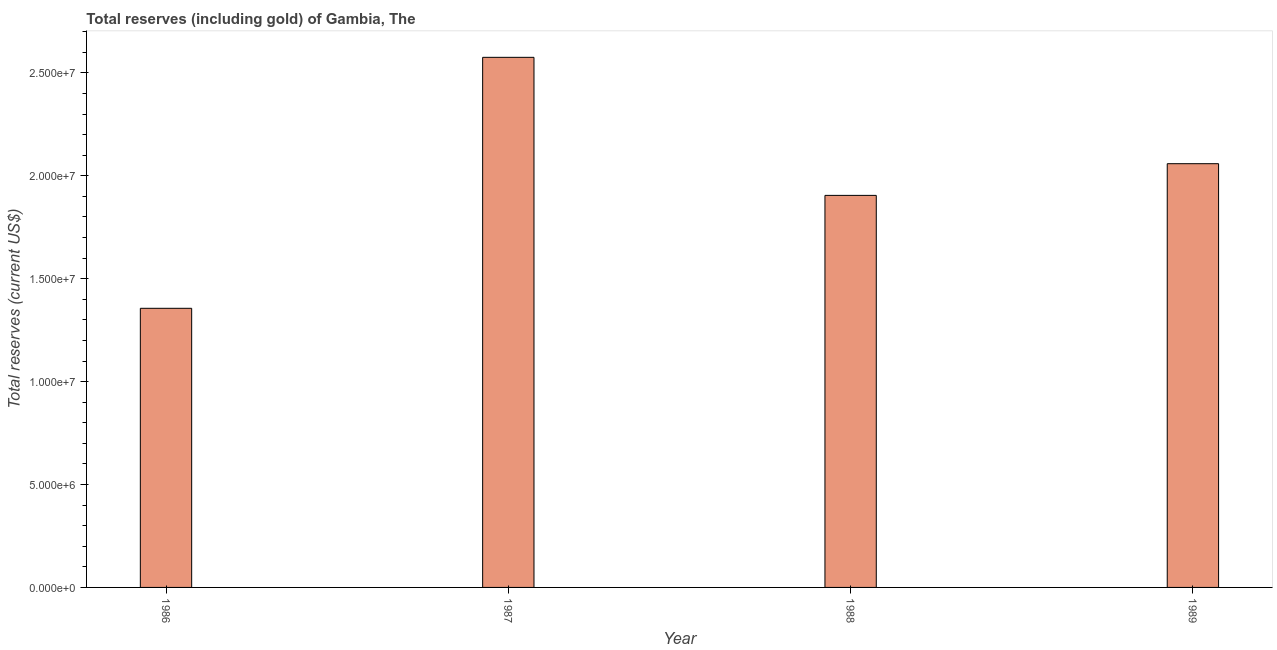Does the graph contain any zero values?
Provide a succinct answer. No. What is the title of the graph?
Offer a terse response. Total reserves (including gold) of Gambia, The. What is the label or title of the Y-axis?
Provide a short and direct response. Total reserves (current US$). What is the total reserves (including gold) in 1989?
Offer a very short reply. 2.06e+07. Across all years, what is the maximum total reserves (including gold)?
Offer a very short reply. 2.58e+07. Across all years, what is the minimum total reserves (including gold)?
Provide a short and direct response. 1.36e+07. What is the sum of the total reserves (including gold)?
Your answer should be compact. 7.90e+07. What is the difference between the total reserves (including gold) in 1986 and 1989?
Your response must be concise. -7.03e+06. What is the average total reserves (including gold) per year?
Provide a succinct answer. 1.97e+07. What is the median total reserves (including gold)?
Provide a succinct answer. 1.98e+07. In how many years, is the total reserves (including gold) greater than 2000000 US$?
Your response must be concise. 4. What is the ratio of the total reserves (including gold) in 1987 to that in 1988?
Your response must be concise. 1.35. What is the difference between the highest and the second highest total reserves (including gold)?
Keep it short and to the point. 5.17e+06. What is the difference between the highest and the lowest total reserves (including gold)?
Ensure brevity in your answer.  1.22e+07. In how many years, is the total reserves (including gold) greater than the average total reserves (including gold) taken over all years?
Your response must be concise. 2. What is the Total reserves (current US$) in 1986?
Make the answer very short. 1.36e+07. What is the Total reserves (current US$) of 1987?
Offer a terse response. 2.58e+07. What is the Total reserves (current US$) in 1988?
Provide a short and direct response. 1.90e+07. What is the Total reserves (current US$) of 1989?
Your response must be concise. 2.06e+07. What is the difference between the Total reserves (current US$) in 1986 and 1987?
Make the answer very short. -1.22e+07. What is the difference between the Total reserves (current US$) in 1986 and 1988?
Your response must be concise. -5.49e+06. What is the difference between the Total reserves (current US$) in 1986 and 1989?
Your response must be concise. -7.03e+06. What is the difference between the Total reserves (current US$) in 1987 and 1988?
Your answer should be compact. 6.71e+06. What is the difference between the Total reserves (current US$) in 1987 and 1989?
Offer a very short reply. 5.17e+06. What is the difference between the Total reserves (current US$) in 1988 and 1989?
Give a very brief answer. -1.54e+06. What is the ratio of the Total reserves (current US$) in 1986 to that in 1987?
Give a very brief answer. 0.53. What is the ratio of the Total reserves (current US$) in 1986 to that in 1988?
Make the answer very short. 0.71. What is the ratio of the Total reserves (current US$) in 1986 to that in 1989?
Give a very brief answer. 0.66. What is the ratio of the Total reserves (current US$) in 1987 to that in 1988?
Offer a terse response. 1.35. What is the ratio of the Total reserves (current US$) in 1987 to that in 1989?
Offer a very short reply. 1.25. What is the ratio of the Total reserves (current US$) in 1988 to that in 1989?
Your answer should be compact. 0.93. 